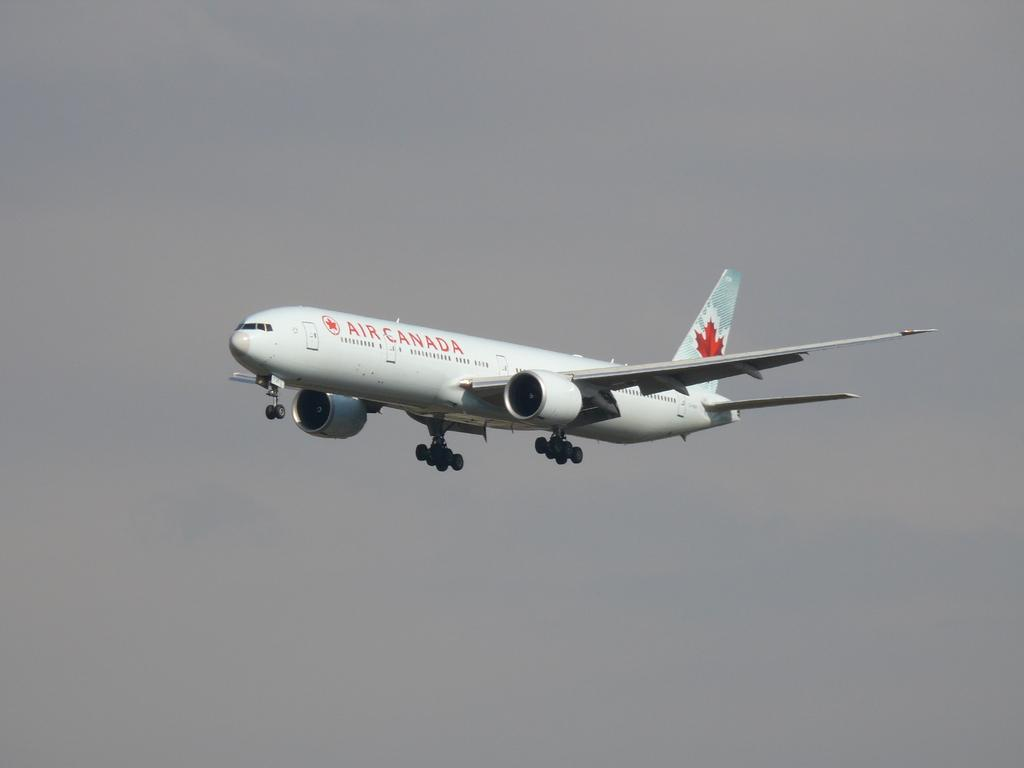<image>
Describe the image concisely. An Air Canada plane is flying in an overcast sky. 